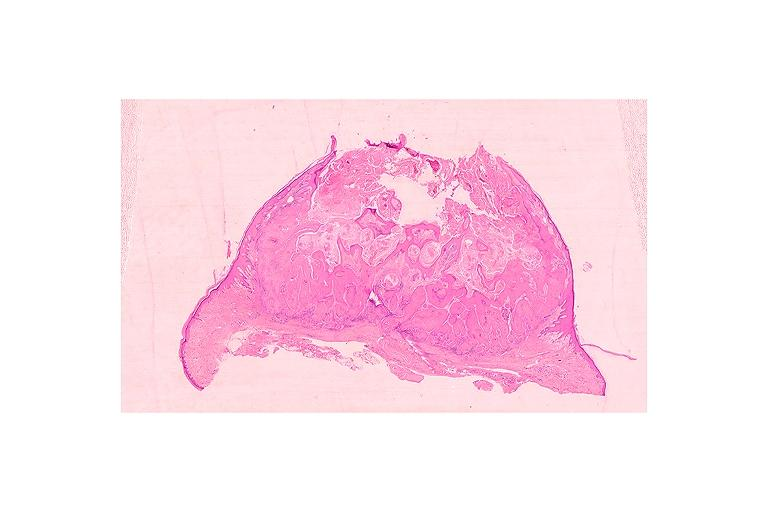what is present?
Answer the question using a single word or phrase. Oral 